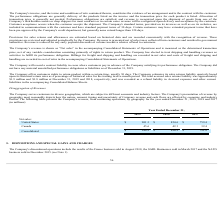According to Systemax's financial document, What does the company's presentation of revenue by geography depict? How the nature, amount, timing and uncertainty of Company revenue and cash flows are affected by economic and industry factors.. The document states: "on of revenue by geography most reasonably depicts how the nature, amount, timing and uncertainty of Company revenue and cash flows are affected by ec..." Also, What is the company's revenue from continuing operations in 2018 and 2019 respectively? The document shows two values: $896.9 and $946.9 (in millions). From the document: "Consolidated $ 946.9 $ 896.9 $ 791.8 Consolidated $ 946.9 $ 896.9 $ 791.8..." Also, What is the company's revenue from continuing operations in 2018 and 2017 respectively? The document shows two values: $896.9 and $791.8 (in millions). From the document: "Consolidated $ 946.9 $ 896.9 $ 791.8 Consolidated $ 946.9 $ 896.9 $ 791.8..." Also, can you calculate: What is the company's total revenue from continuing operations in 2018 and 2019? Based on the calculation: 946.9 + 896.9 , the result is 1843.8 (in millions). This is based on the information: "Consolidated $ 946.9 $ 896.9 $ 791.8 Consolidated $ 946.9 $ 896.9 $ 791.8..." The key data points involved are: 896.9, 946.9. Also, can you calculate: What is the company's total revenue from continuing operations in 2018 and 2017? Based on the calculation: 791.8 + 896.9 , the result is 1688.7 (in millions). This is based on the information: "Consolidated $ 946.9 $ 896.9 $ 791.8 Consolidated $ 946.9 $ 896.9 $ 791.8..." The key data points involved are: 791.8, 896.9. Also, can you calculate: What is the percentage change in the company's revenue from continuing operations between 2018 and 2019? To answer this question, I need to perform calculations using the financial data. The calculation is: (946.9 - 896.9)/896.9 , which equals 5.57 (percentage). This is based on the information: "Consolidated $ 946.9 $ 896.9 $ 791.8 Consolidated $ 946.9 $ 896.9 $ 791.8..." The key data points involved are: 896.9, 946.9. 